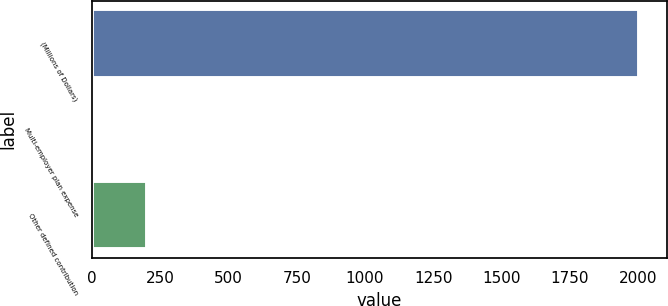<chart> <loc_0><loc_0><loc_500><loc_500><bar_chart><fcel>(Millions of Dollars)<fcel>Multi-employer plan expense<fcel>Other defined contribution<nl><fcel>2004<fcel>0.4<fcel>200.76<nl></chart> 